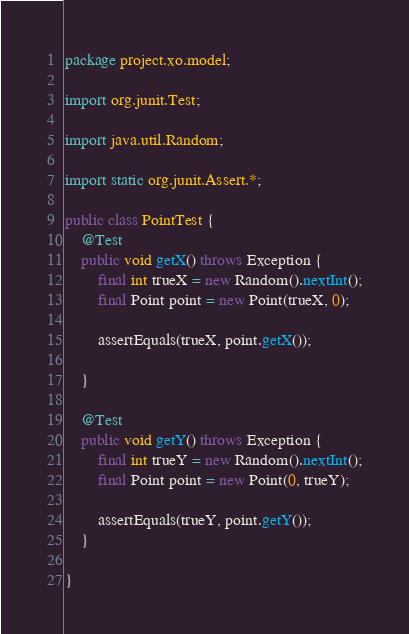Convert code to text. <code><loc_0><loc_0><loc_500><loc_500><_Java_>package project.xo.model;

import org.junit.Test;

import java.util.Random;

import static org.junit.Assert.*;

public class PointTest {
    @Test
    public void getX() throws Exception {
        final int trueX = new Random().nextInt();
        final Point point = new Point(trueX, 0);

        assertEquals(trueX, point.getX());

    }

    @Test
    public void getY() throws Exception {
        final int trueY = new Random().nextInt();
        final Point point = new Point(0, trueY);

        assertEquals(trueY, point.getY());
    }

}</code> 